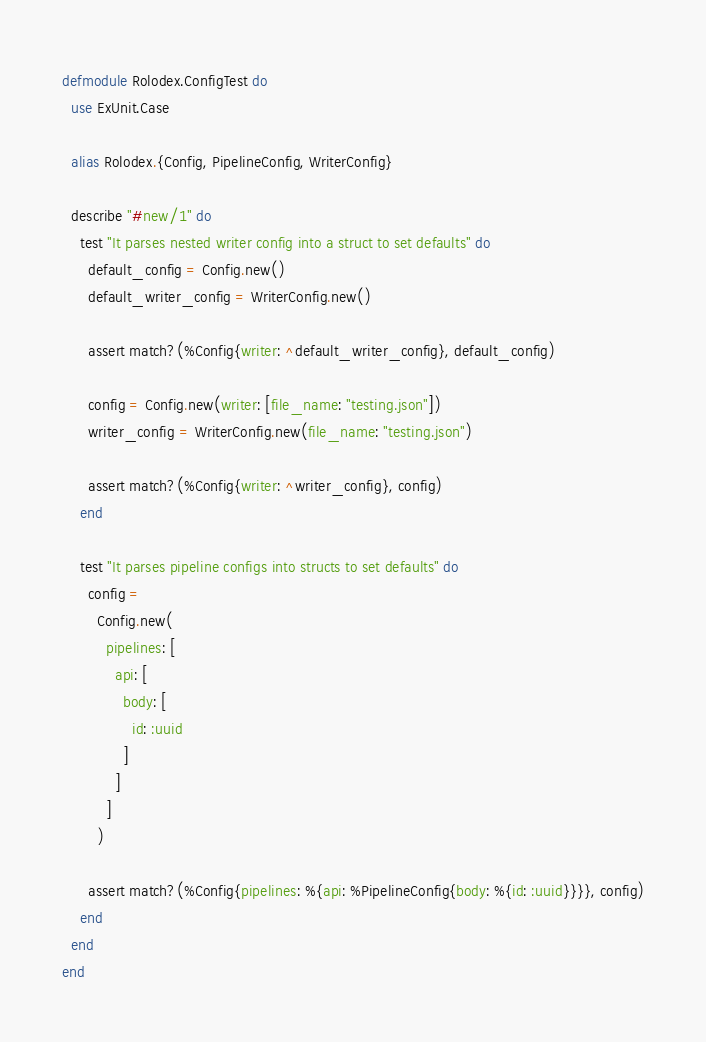<code> <loc_0><loc_0><loc_500><loc_500><_Elixir_>defmodule Rolodex.ConfigTest do
  use ExUnit.Case

  alias Rolodex.{Config, PipelineConfig, WriterConfig}

  describe "#new/1" do
    test "It parses nested writer config into a struct to set defaults" do
      default_config = Config.new()
      default_writer_config = WriterConfig.new()

      assert match?(%Config{writer: ^default_writer_config}, default_config)

      config = Config.new(writer: [file_name: "testing.json"])
      writer_config = WriterConfig.new(file_name: "testing.json")

      assert match?(%Config{writer: ^writer_config}, config)
    end

    test "It parses pipeline configs into structs to set defaults" do
      config =
        Config.new(
          pipelines: [
            api: [
              body: [
                id: :uuid
              ]
            ]
          ]
        )

      assert match?(%Config{pipelines: %{api: %PipelineConfig{body: %{id: :uuid}}}}, config)
    end
  end
end
</code> 